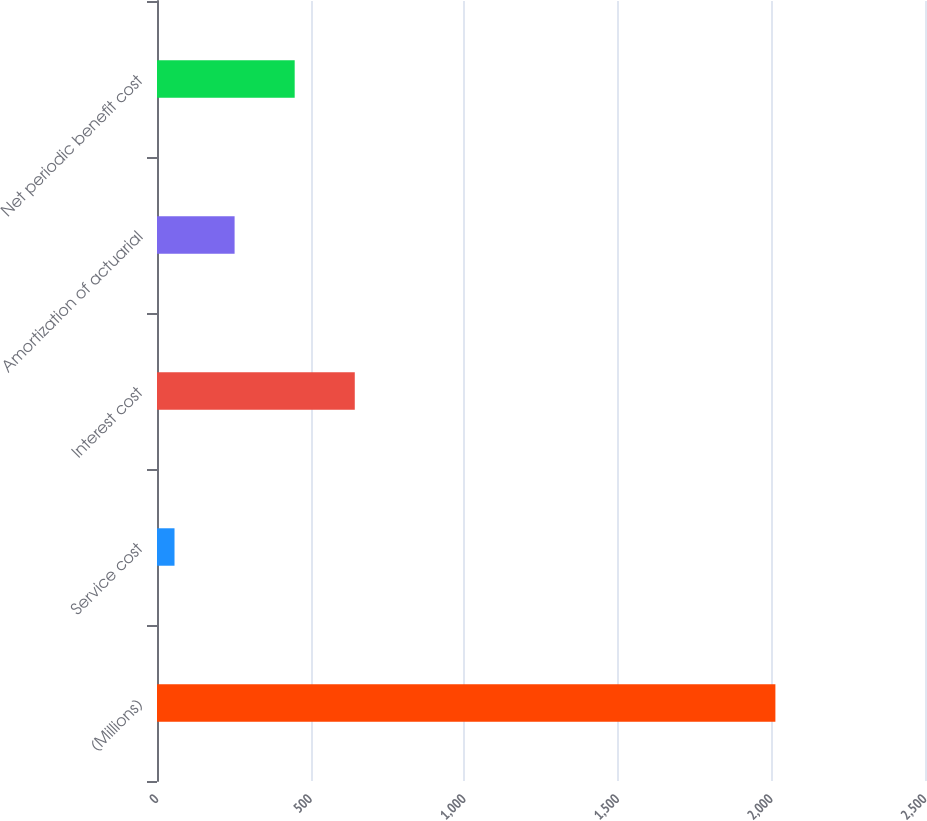Convert chart to OTSL. <chart><loc_0><loc_0><loc_500><loc_500><bar_chart><fcel>(Millions)<fcel>Service cost<fcel>Interest cost<fcel>Amortization of actuarial<fcel>Net periodic benefit cost<nl><fcel>2013<fcel>57<fcel>643.8<fcel>252.6<fcel>448.2<nl></chart> 